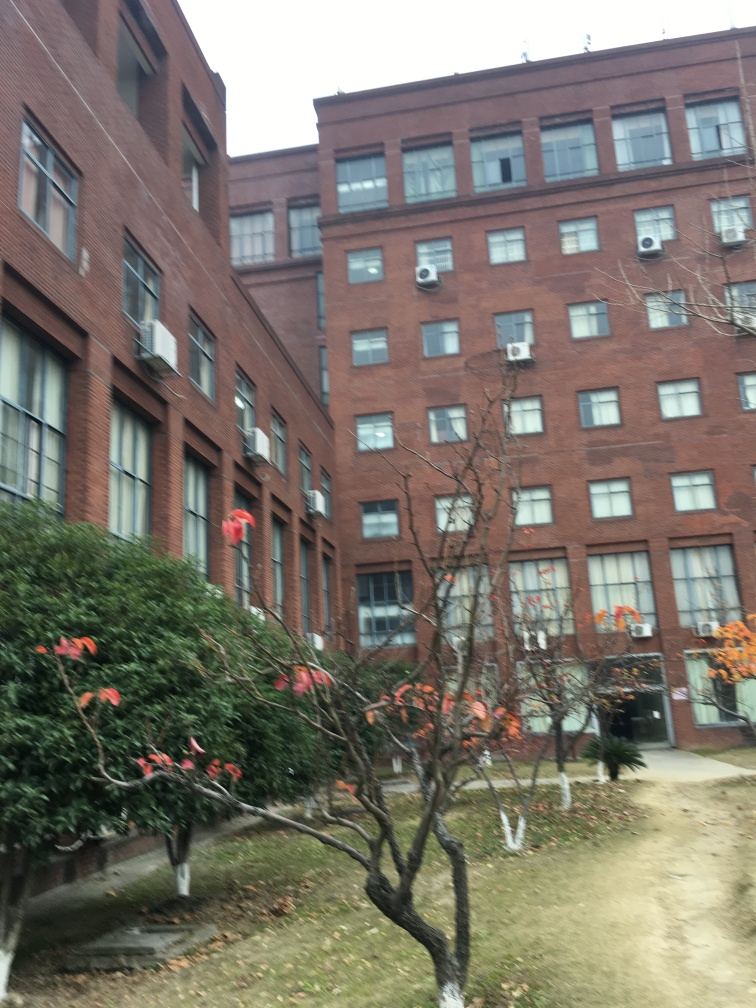What can you say about the architecture of the building? The building has a brick facade with a repeating pattern of windows. It is likely an older construction, possibly a converted industrial or warehouse building now used for residential or commercial purposes. 